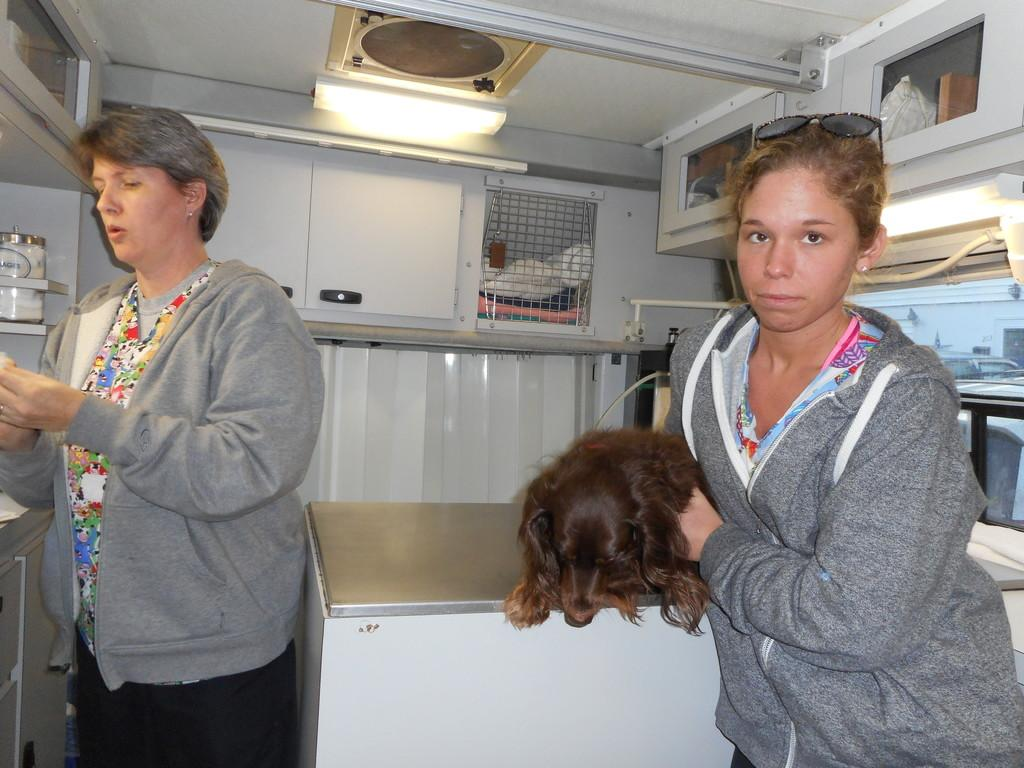Who is present in the image? There is a woman in the image. What is the woman wearing? The woman is wearing a jacket. What is the woman doing in the image? The woman is standing and holding a dog. Can you describe the lighting in the image? There is a light visible in the image. What can be seen inside the cupboards in the image? The cupboards in the image are filled with things. What type of containers are on the furniture in the image? There are jars on the furniture in the image. What is the woman's annual income in the image? There is no information about the woman's income in the image. How does the wheel in the image contribute to the scene? There is no wheel present in the image. 